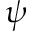<formula> <loc_0><loc_0><loc_500><loc_500>\psi</formula> 